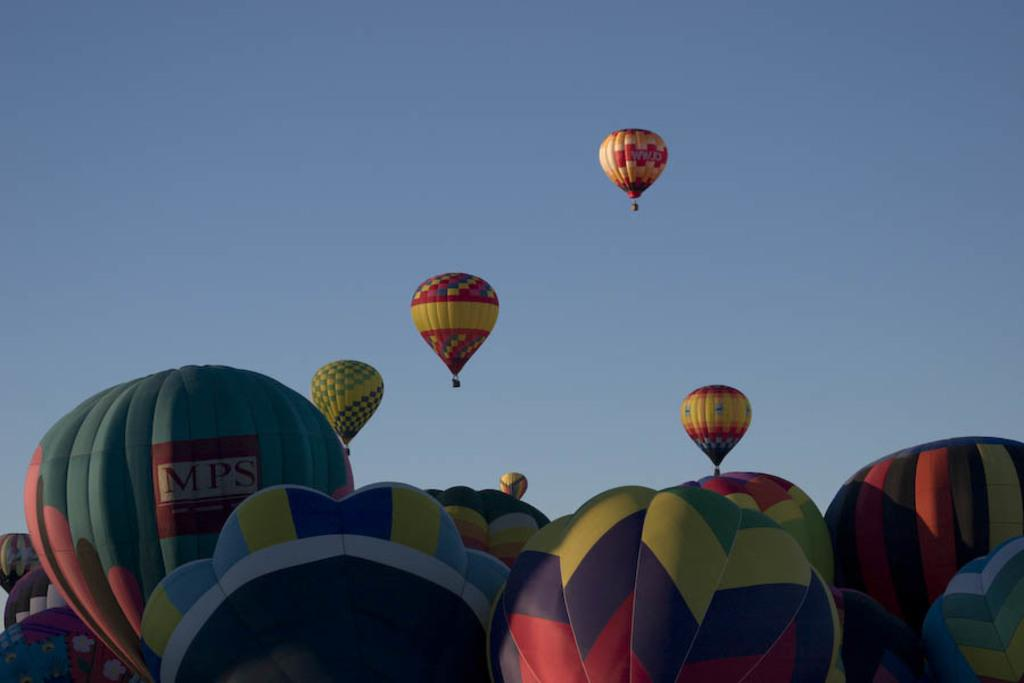What is the main subject of the image? The main subject of the image is hot air balloons. Where are the hot air balloons located in the image? The hot air balloons are in the air. What can be seen in the background of the image? The sky is visible in the image. Can you tell me how many stores are visible in the image? There are no stores present in the image; it features hot air balloons in the air. What type of bat is flying near the hot air balloons in the image? There is no bat present in the image; it only features hot air balloons in the air. 